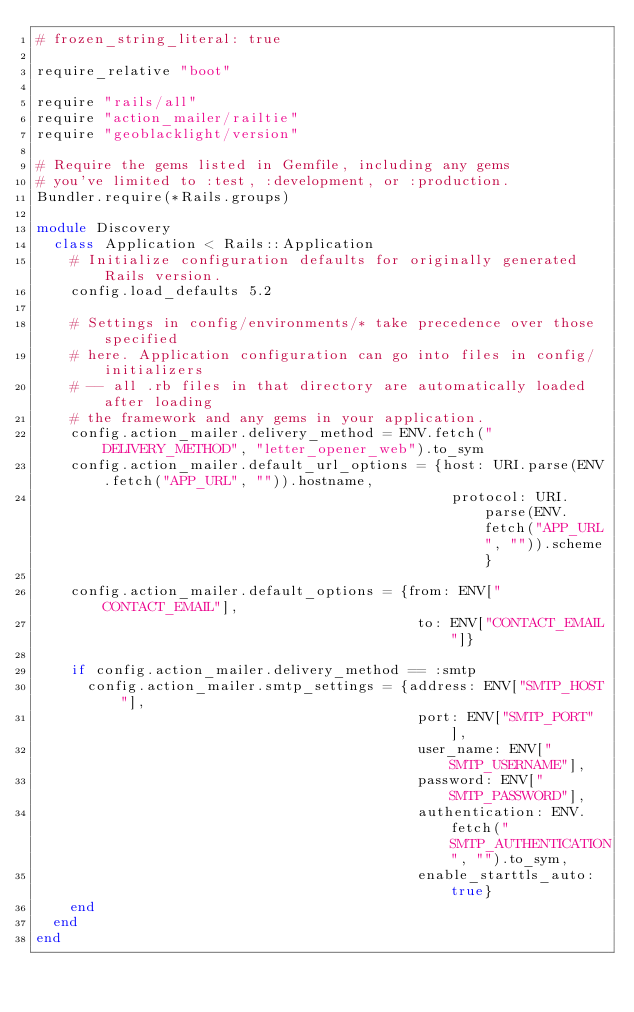Convert code to text. <code><loc_0><loc_0><loc_500><loc_500><_Ruby_># frozen_string_literal: true

require_relative "boot"

require "rails/all"
require "action_mailer/railtie"
require "geoblacklight/version"

# Require the gems listed in Gemfile, including any gems
# you've limited to :test, :development, or :production.
Bundler.require(*Rails.groups)

module Discovery
  class Application < Rails::Application
    # Initialize configuration defaults for originally generated Rails version.
    config.load_defaults 5.2

    # Settings in config/environments/* take precedence over those specified
    # here. Application configuration can go into files in config/initializers
    # -- all .rb files in that directory are automatically loaded after loading
    # the framework and any gems in your application.
    config.action_mailer.delivery_method = ENV.fetch("DELIVERY_METHOD", "letter_opener_web").to_sym
    config.action_mailer.default_url_options = {host: URI.parse(ENV.fetch("APP_URL", "")).hostname,
                                                 protocol: URI.parse(ENV.fetch("APP_URL", "")).scheme}

    config.action_mailer.default_options = {from: ENV["CONTACT_EMAIL"],
                                             to: ENV["CONTACT_EMAIL"]}

    if config.action_mailer.delivery_method == :smtp
      config.action_mailer.smtp_settings = {address: ENV["SMTP_HOST"],
                                             port: ENV["SMTP_PORT"],
                                             user_name: ENV["SMTP_USERNAME"],
                                             password: ENV["SMTP_PASSWORD"],
                                             authentication: ENV.fetch("SMTP_AUTHENTICATION", "").to_sym,
                                             enable_starttls_auto: true}
    end
  end
end
</code> 